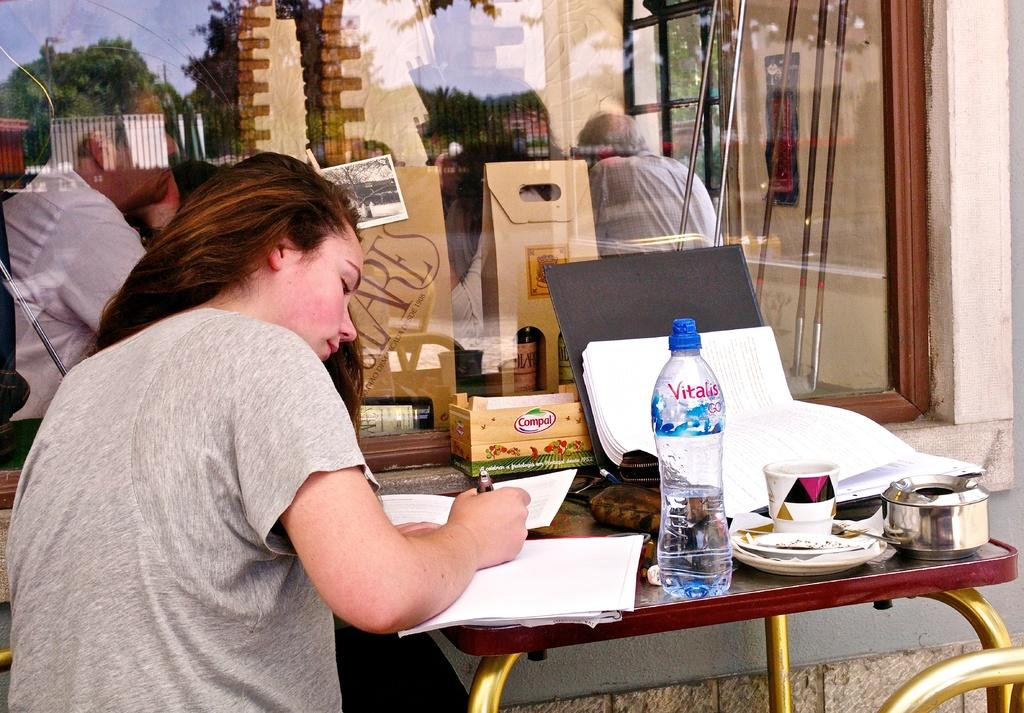Who is the main subject in the image? There is a woman in the image. What is the woman doing in the image? The woman is writing on a paper. What objects can be seen on the table in the image? There is a cup and a water bottle on the table. Can you describe the background of the image? There are people visible in the background of the image. What type of hook is the woman using to write on the paper in the image? There is no hook present in the image; the woman is using a pen or pencil to write on the paper. What does the woman need to complete her task in the image? The woman already has the necessary tools to complete her task, which is a pen or pencil and paper. 